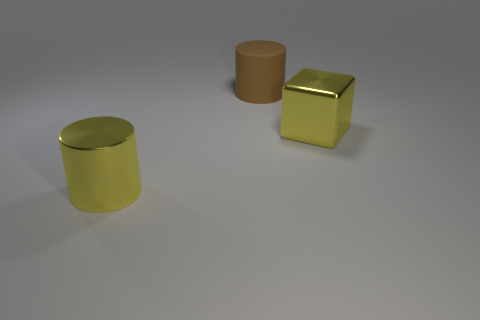Add 1 gray metal balls. How many objects exist? 4 Subtract all cylinders. How many objects are left? 1 Subtract all blue balls. How many yellow cylinders are left? 1 Subtract all big red balls. Subtract all yellow metallic things. How many objects are left? 1 Add 3 large metallic objects. How many large metallic objects are left? 5 Add 1 brown cylinders. How many brown cylinders exist? 2 Subtract all yellow cylinders. How many cylinders are left? 1 Subtract 0 purple spheres. How many objects are left? 3 Subtract 2 cylinders. How many cylinders are left? 0 Subtract all brown cylinders. Subtract all gray blocks. How many cylinders are left? 1 